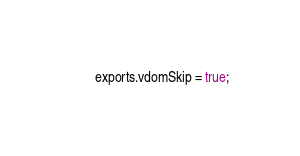Convert code to text. <code><loc_0><loc_0><loc_500><loc_500><_JavaScript_>
exports.vdomSkip = true;
</code> 